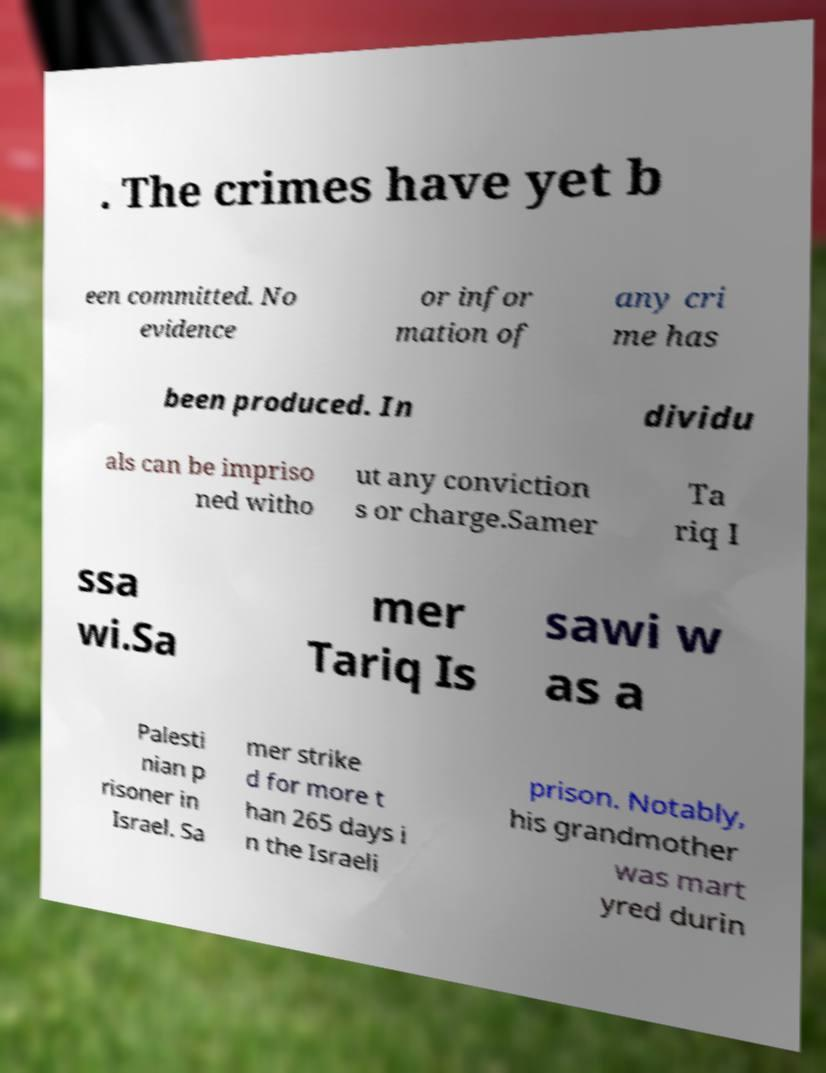Can you accurately transcribe the text from the provided image for me? . The crimes have yet b een committed. No evidence or infor mation of any cri me has been produced. In dividu als can be impriso ned witho ut any conviction s or charge.Samer Ta riq I ssa wi.Sa mer Tariq Is sawi w as a Palesti nian p risoner in Israel. Sa mer strike d for more t han 265 days i n the Israeli prison. Notably, his grandmother was mart yred durin 